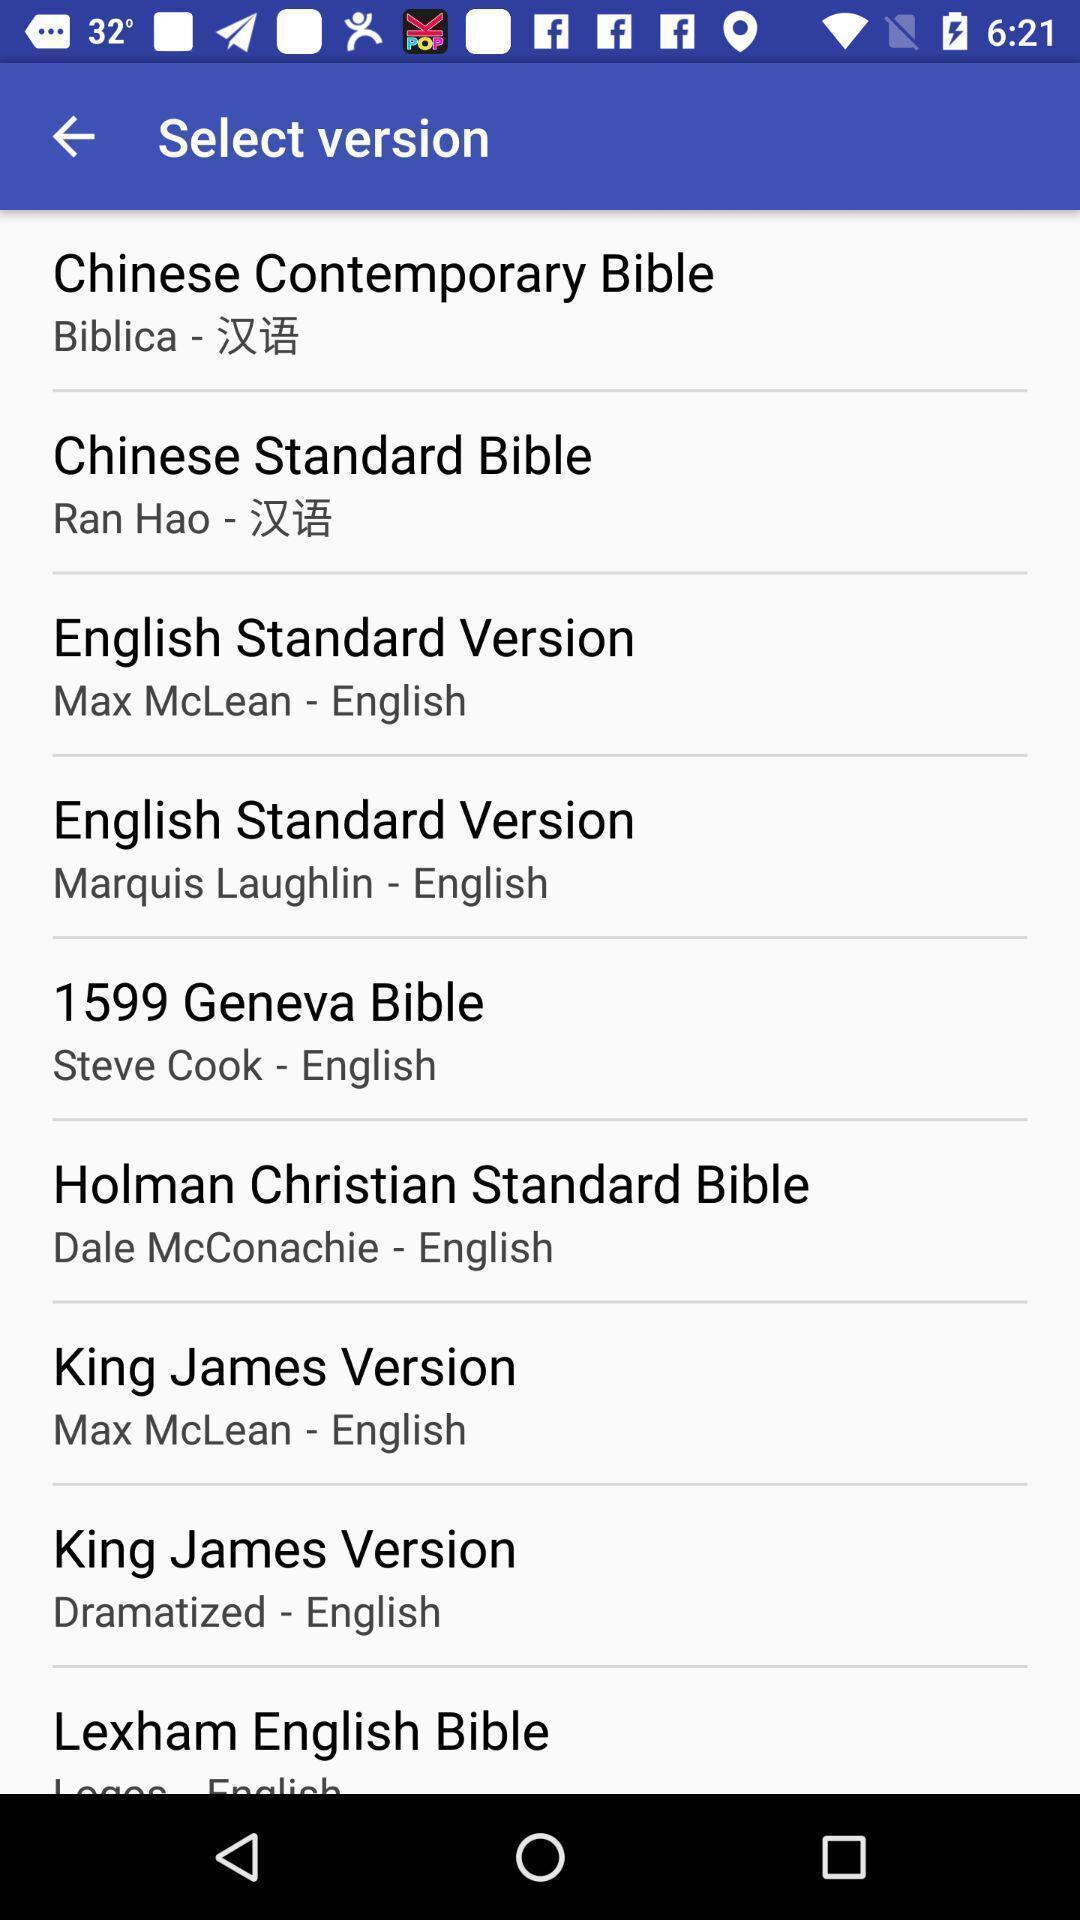What details can you identify in this image? Page showing of different versions available. 